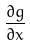<formula> <loc_0><loc_0><loc_500><loc_500>\frac { \partial g } { \partial x }</formula> 